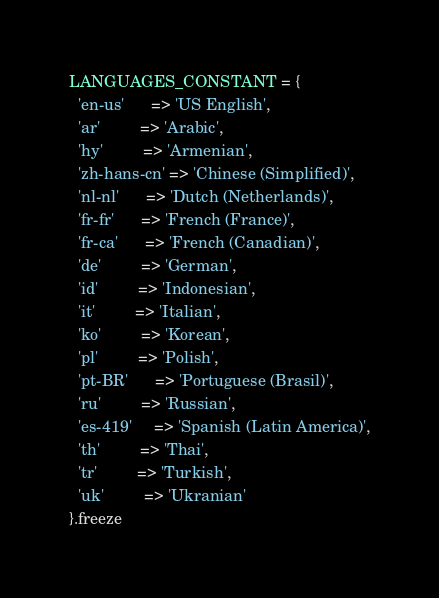Convert code to text. <code><loc_0><loc_0><loc_500><loc_500><_Ruby_>LANGUAGES_CONSTANT = {
  'en-us'      => 'US English',
  'ar'         => 'Arabic',
  'hy'         => 'Armenian',
  'zh-hans-cn' => 'Chinese (Simplified)',
  'nl-nl'      => 'Dutch (Netherlands)',
  'fr-fr'      => 'French (France)',
  'fr-ca'      => 'French (Canadian)',
  'de'         => 'German',
  'id'         => 'Indonesian',
  'it'         => 'Italian',
  'ko'         => 'Korean',
  'pl'         => 'Polish',
  'pt-BR'      => 'Portuguese (Brasil)',
  'ru'         => 'Russian',
  'es-419'     => 'Spanish (Latin America)',
  'th'         => 'Thai',
  'tr'         => 'Turkish',
  'uk'         => 'Ukranian'
}.freeze
</code> 